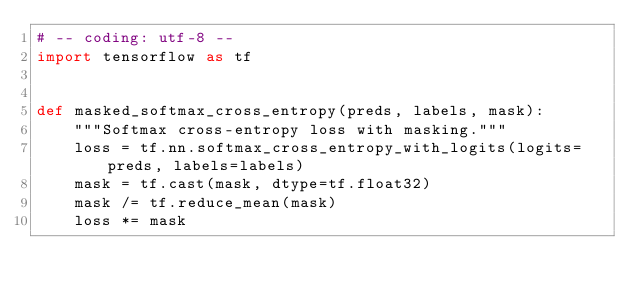<code> <loc_0><loc_0><loc_500><loc_500><_Python_># -- coding: utf-8 --
import tensorflow as tf


def masked_softmax_cross_entropy(preds, labels, mask):
    """Softmax cross-entropy loss with masking."""
    loss = tf.nn.softmax_cross_entropy_with_logits(logits=preds, labels=labels)
    mask = tf.cast(mask, dtype=tf.float32)
    mask /= tf.reduce_mean(mask)
    loss *= mask</code> 